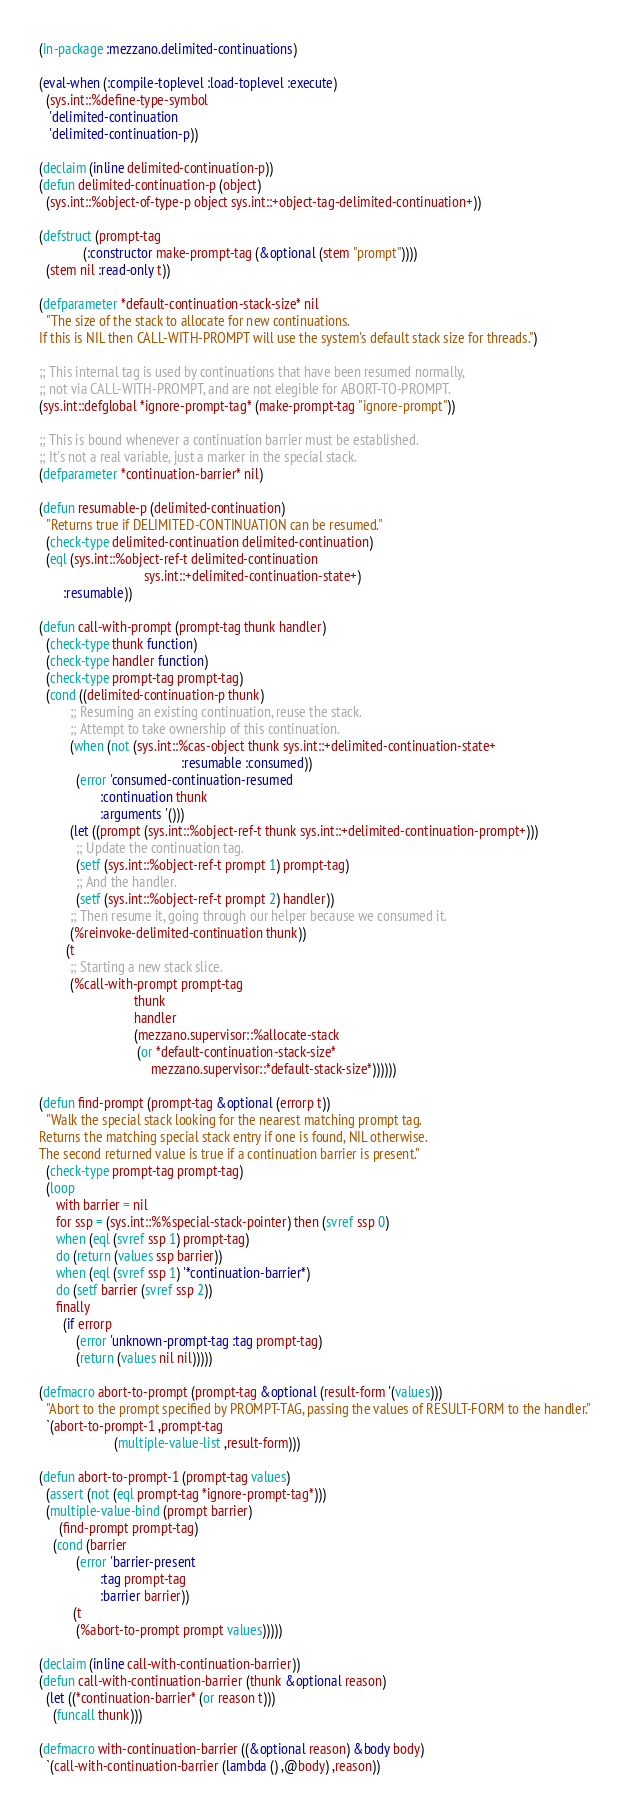<code> <loc_0><loc_0><loc_500><loc_500><_Lisp_>(in-package :mezzano.delimited-continuations)

(eval-when (:compile-toplevel :load-toplevel :execute)
  (sys.int::%define-type-symbol
   'delimited-continuation
   'delimited-continuation-p))

(declaim (inline delimited-continuation-p))
(defun delimited-continuation-p (object)
  (sys.int::%object-of-type-p object sys.int::+object-tag-delimited-continuation+))

(defstruct (prompt-tag
             (:constructor make-prompt-tag (&optional (stem "prompt"))))
  (stem nil :read-only t))

(defparameter *default-continuation-stack-size* nil
  "The size of the stack to allocate for new continuations.
If this is NIL then CALL-WITH-PROMPT will use the system's default stack size for threads.")

;; This internal tag is used by continuations that have been resumed normally,
;; not via CALL-WITH-PROMPT, and are not elegible for ABORT-TO-PROMPT.
(sys.int::defglobal *ignore-prompt-tag* (make-prompt-tag "ignore-prompt"))

;; This is bound whenever a continuation barrier must be established.
;; It's not a real variable, just a marker in the special stack.
(defparameter *continuation-barrier* nil)

(defun resumable-p (delimited-continuation)
  "Returns true if DELIMITED-CONTINUATION can be resumed."
  (check-type delimited-continuation delimited-continuation)
  (eql (sys.int::%object-ref-t delimited-continuation
                               sys.int::+delimited-continuation-state+)
       :resumable))

(defun call-with-prompt (prompt-tag thunk handler)
  (check-type thunk function)
  (check-type handler function)
  (check-type prompt-tag prompt-tag)
  (cond ((delimited-continuation-p thunk)
         ;; Resuming an existing continuation, reuse the stack.
         ;; Attempt to take ownership of this continuation.
         (when (not (sys.int::%cas-object thunk sys.int::+delimited-continuation-state+
                                          :resumable :consumed))
           (error 'consumed-continuation-resumed
                  :continuation thunk
                  :arguments '()))
         (let ((prompt (sys.int::%object-ref-t thunk sys.int::+delimited-continuation-prompt+)))
           ;; Update the continuation tag.
           (setf (sys.int::%object-ref-t prompt 1) prompt-tag)
           ;; And the handler.
           (setf (sys.int::%object-ref-t prompt 2) handler))
         ;; Then resume it, going through our helper because we consumed it.
         (%reinvoke-delimited-continuation thunk))
        (t
         ;; Starting a new stack slice.
         (%call-with-prompt prompt-tag
                            thunk
                            handler
                            (mezzano.supervisor::%allocate-stack
                             (or *default-continuation-stack-size*
                                 mezzano.supervisor::*default-stack-size*))))))

(defun find-prompt (prompt-tag &optional (errorp t))
  "Walk the special stack looking for the nearest matching prompt tag.
Returns the matching special stack entry if one is found, NIL otherwise.
The second returned value is true if a continuation barrier is present."
  (check-type prompt-tag prompt-tag)
  (loop
     with barrier = nil
     for ssp = (sys.int::%%special-stack-pointer) then (svref ssp 0)
     when (eql (svref ssp 1) prompt-tag)
     do (return (values ssp barrier))
     when (eql (svref ssp 1) '*continuation-barrier*)
     do (setf barrier (svref ssp 2))
     finally
       (if errorp
           (error 'unknown-prompt-tag :tag prompt-tag)
           (return (values nil nil)))))

(defmacro abort-to-prompt (prompt-tag &optional (result-form '(values)))
  "Abort to the prompt specified by PROMPT-TAG, passing the values of RESULT-FORM to the handler."
  `(abort-to-prompt-1 ,prompt-tag
                      (multiple-value-list ,result-form)))

(defun abort-to-prompt-1 (prompt-tag values)
  (assert (not (eql prompt-tag *ignore-prompt-tag*)))
  (multiple-value-bind (prompt barrier)
      (find-prompt prompt-tag)
    (cond (barrier
           (error 'barrier-present
                  :tag prompt-tag
                  :barrier barrier))
          (t
           (%abort-to-prompt prompt values)))))

(declaim (inline call-with-continuation-barrier))
(defun call-with-continuation-barrier (thunk &optional reason)
  (let ((*continuation-barrier* (or reason t)))
    (funcall thunk)))

(defmacro with-continuation-barrier ((&optional reason) &body body)
  `(call-with-continuation-barrier (lambda () ,@body) ,reason))
</code> 